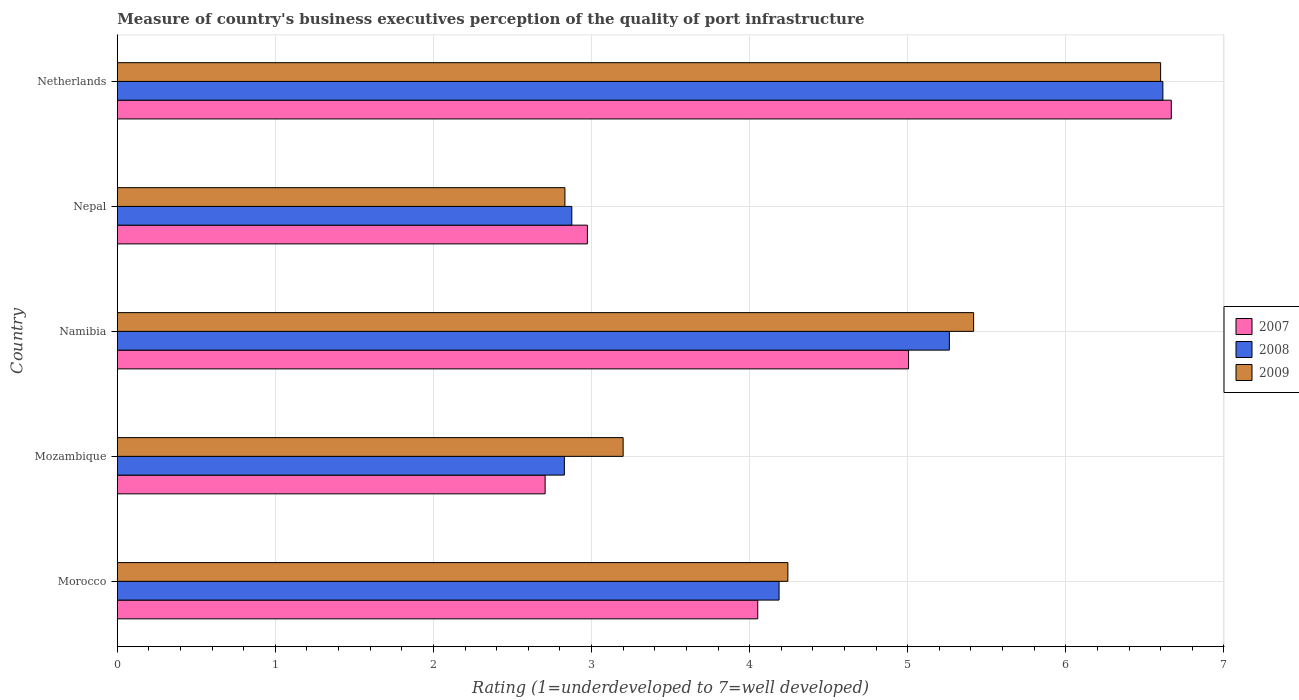How many groups of bars are there?
Ensure brevity in your answer.  5. Are the number of bars on each tick of the Y-axis equal?
Keep it short and to the point. Yes. How many bars are there on the 2nd tick from the bottom?
Offer a terse response. 3. What is the label of the 4th group of bars from the top?
Ensure brevity in your answer.  Mozambique. In how many cases, is the number of bars for a given country not equal to the number of legend labels?
Offer a terse response. 0. What is the ratings of the quality of port infrastructure in 2009 in Mozambique?
Provide a succinct answer. 3.2. Across all countries, what is the maximum ratings of the quality of port infrastructure in 2009?
Your answer should be very brief. 6.6. Across all countries, what is the minimum ratings of the quality of port infrastructure in 2007?
Your response must be concise. 2.71. In which country was the ratings of the quality of port infrastructure in 2007 minimum?
Provide a succinct answer. Mozambique. What is the total ratings of the quality of port infrastructure in 2007 in the graph?
Give a very brief answer. 21.4. What is the difference between the ratings of the quality of port infrastructure in 2009 in Nepal and that in Netherlands?
Make the answer very short. -3.77. What is the difference between the ratings of the quality of port infrastructure in 2008 in Namibia and the ratings of the quality of port infrastructure in 2009 in Mozambique?
Your answer should be very brief. 2.06. What is the average ratings of the quality of port infrastructure in 2008 per country?
Ensure brevity in your answer.  4.35. What is the difference between the ratings of the quality of port infrastructure in 2008 and ratings of the quality of port infrastructure in 2007 in Netherlands?
Give a very brief answer. -0.05. What is the ratio of the ratings of the quality of port infrastructure in 2009 in Mozambique to that in Namibia?
Provide a succinct answer. 0.59. Is the difference between the ratings of the quality of port infrastructure in 2008 in Morocco and Mozambique greater than the difference between the ratings of the quality of port infrastructure in 2007 in Morocco and Mozambique?
Keep it short and to the point. Yes. What is the difference between the highest and the second highest ratings of the quality of port infrastructure in 2007?
Offer a very short reply. 1.66. What is the difference between the highest and the lowest ratings of the quality of port infrastructure in 2008?
Make the answer very short. 3.79. What does the 1st bar from the top in Namibia represents?
Provide a succinct answer. 2009. What does the 2nd bar from the bottom in Netherlands represents?
Your response must be concise. 2008. Is it the case that in every country, the sum of the ratings of the quality of port infrastructure in 2009 and ratings of the quality of port infrastructure in 2008 is greater than the ratings of the quality of port infrastructure in 2007?
Keep it short and to the point. Yes. How many bars are there?
Offer a terse response. 15. Are all the bars in the graph horizontal?
Ensure brevity in your answer.  Yes. Are the values on the major ticks of X-axis written in scientific E-notation?
Offer a terse response. No. How are the legend labels stacked?
Your answer should be compact. Vertical. What is the title of the graph?
Your response must be concise. Measure of country's business executives perception of the quality of port infrastructure. Does "1992" appear as one of the legend labels in the graph?
Make the answer very short. No. What is the label or title of the X-axis?
Provide a short and direct response. Rating (1=underdeveloped to 7=well developed). What is the Rating (1=underdeveloped to 7=well developed) in 2007 in Morocco?
Your answer should be very brief. 4.05. What is the Rating (1=underdeveloped to 7=well developed) in 2008 in Morocco?
Provide a short and direct response. 4.19. What is the Rating (1=underdeveloped to 7=well developed) of 2009 in Morocco?
Offer a terse response. 4.24. What is the Rating (1=underdeveloped to 7=well developed) in 2007 in Mozambique?
Provide a succinct answer. 2.71. What is the Rating (1=underdeveloped to 7=well developed) of 2008 in Mozambique?
Offer a very short reply. 2.83. What is the Rating (1=underdeveloped to 7=well developed) of 2009 in Mozambique?
Give a very brief answer. 3.2. What is the Rating (1=underdeveloped to 7=well developed) of 2007 in Namibia?
Your answer should be very brief. 5.01. What is the Rating (1=underdeveloped to 7=well developed) in 2008 in Namibia?
Give a very brief answer. 5.26. What is the Rating (1=underdeveloped to 7=well developed) in 2009 in Namibia?
Offer a terse response. 5.42. What is the Rating (1=underdeveloped to 7=well developed) of 2007 in Nepal?
Give a very brief answer. 2.97. What is the Rating (1=underdeveloped to 7=well developed) in 2008 in Nepal?
Your answer should be compact. 2.88. What is the Rating (1=underdeveloped to 7=well developed) of 2009 in Nepal?
Your answer should be compact. 2.83. What is the Rating (1=underdeveloped to 7=well developed) of 2007 in Netherlands?
Offer a terse response. 6.67. What is the Rating (1=underdeveloped to 7=well developed) in 2008 in Netherlands?
Provide a succinct answer. 6.61. What is the Rating (1=underdeveloped to 7=well developed) of 2009 in Netherlands?
Your answer should be very brief. 6.6. Across all countries, what is the maximum Rating (1=underdeveloped to 7=well developed) in 2007?
Your answer should be very brief. 6.67. Across all countries, what is the maximum Rating (1=underdeveloped to 7=well developed) in 2008?
Your answer should be very brief. 6.61. Across all countries, what is the maximum Rating (1=underdeveloped to 7=well developed) of 2009?
Keep it short and to the point. 6.6. Across all countries, what is the minimum Rating (1=underdeveloped to 7=well developed) of 2007?
Your answer should be compact. 2.71. Across all countries, what is the minimum Rating (1=underdeveloped to 7=well developed) in 2008?
Ensure brevity in your answer.  2.83. Across all countries, what is the minimum Rating (1=underdeveloped to 7=well developed) of 2009?
Your answer should be compact. 2.83. What is the total Rating (1=underdeveloped to 7=well developed) of 2007 in the graph?
Provide a succinct answer. 21.4. What is the total Rating (1=underdeveloped to 7=well developed) in 2008 in the graph?
Your response must be concise. 21.77. What is the total Rating (1=underdeveloped to 7=well developed) in 2009 in the graph?
Give a very brief answer. 22.29. What is the difference between the Rating (1=underdeveloped to 7=well developed) in 2007 in Morocco and that in Mozambique?
Your answer should be very brief. 1.34. What is the difference between the Rating (1=underdeveloped to 7=well developed) of 2008 in Morocco and that in Mozambique?
Ensure brevity in your answer.  1.36. What is the difference between the Rating (1=underdeveloped to 7=well developed) in 2009 in Morocco and that in Mozambique?
Keep it short and to the point. 1.04. What is the difference between the Rating (1=underdeveloped to 7=well developed) of 2007 in Morocco and that in Namibia?
Your response must be concise. -0.95. What is the difference between the Rating (1=underdeveloped to 7=well developed) in 2008 in Morocco and that in Namibia?
Offer a very short reply. -1.08. What is the difference between the Rating (1=underdeveloped to 7=well developed) in 2009 in Morocco and that in Namibia?
Keep it short and to the point. -1.18. What is the difference between the Rating (1=underdeveloped to 7=well developed) of 2007 in Morocco and that in Nepal?
Provide a short and direct response. 1.08. What is the difference between the Rating (1=underdeveloped to 7=well developed) of 2008 in Morocco and that in Nepal?
Ensure brevity in your answer.  1.31. What is the difference between the Rating (1=underdeveloped to 7=well developed) of 2009 in Morocco and that in Nepal?
Provide a succinct answer. 1.41. What is the difference between the Rating (1=underdeveloped to 7=well developed) of 2007 in Morocco and that in Netherlands?
Keep it short and to the point. -2.62. What is the difference between the Rating (1=underdeveloped to 7=well developed) in 2008 in Morocco and that in Netherlands?
Your answer should be compact. -2.43. What is the difference between the Rating (1=underdeveloped to 7=well developed) of 2009 in Morocco and that in Netherlands?
Ensure brevity in your answer.  -2.36. What is the difference between the Rating (1=underdeveloped to 7=well developed) of 2007 in Mozambique and that in Namibia?
Your response must be concise. -2.3. What is the difference between the Rating (1=underdeveloped to 7=well developed) in 2008 in Mozambique and that in Namibia?
Give a very brief answer. -2.44. What is the difference between the Rating (1=underdeveloped to 7=well developed) of 2009 in Mozambique and that in Namibia?
Your response must be concise. -2.22. What is the difference between the Rating (1=underdeveloped to 7=well developed) in 2007 in Mozambique and that in Nepal?
Ensure brevity in your answer.  -0.27. What is the difference between the Rating (1=underdeveloped to 7=well developed) of 2008 in Mozambique and that in Nepal?
Your response must be concise. -0.05. What is the difference between the Rating (1=underdeveloped to 7=well developed) of 2009 in Mozambique and that in Nepal?
Provide a succinct answer. 0.37. What is the difference between the Rating (1=underdeveloped to 7=well developed) in 2007 in Mozambique and that in Netherlands?
Provide a succinct answer. -3.96. What is the difference between the Rating (1=underdeveloped to 7=well developed) in 2008 in Mozambique and that in Netherlands?
Your answer should be very brief. -3.79. What is the difference between the Rating (1=underdeveloped to 7=well developed) of 2009 in Mozambique and that in Netherlands?
Ensure brevity in your answer.  -3.4. What is the difference between the Rating (1=underdeveloped to 7=well developed) of 2007 in Namibia and that in Nepal?
Provide a short and direct response. 2.03. What is the difference between the Rating (1=underdeveloped to 7=well developed) of 2008 in Namibia and that in Nepal?
Make the answer very short. 2.39. What is the difference between the Rating (1=underdeveloped to 7=well developed) in 2009 in Namibia and that in Nepal?
Keep it short and to the point. 2.59. What is the difference between the Rating (1=underdeveloped to 7=well developed) in 2007 in Namibia and that in Netherlands?
Provide a succinct answer. -1.66. What is the difference between the Rating (1=underdeveloped to 7=well developed) of 2008 in Namibia and that in Netherlands?
Give a very brief answer. -1.35. What is the difference between the Rating (1=underdeveloped to 7=well developed) of 2009 in Namibia and that in Netherlands?
Keep it short and to the point. -1.18. What is the difference between the Rating (1=underdeveloped to 7=well developed) in 2007 in Nepal and that in Netherlands?
Keep it short and to the point. -3.69. What is the difference between the Rating (1=underdeveloped to 7=well developed) of 2008 in Nepal and that in Netherlands?
Give a very brief answer. -3.74. What is the difference between the Rating (1=underdeveloped to 7=well developed) of 2009 in Nepal and that in Netherlands?
Offer a very short reply. -3.77. What is the difference between the Rating (1=underdeveloped to 7=well developed) in 2007 in Morocco and the Rating (1=underdeveloped to 7=well developed) in 2008 in Mozambique?
Your answer should be compact. 1.22. What is the difference between the Rating (1=underdeveloped to 7=well developed) in 2007 in Morocco and the Rating (1=underdeveloped to 7=well developed) in 2009 in Mozambique?
Ensure brevity in your answer.  0.85. What is the difference between the Rating (1=underdeveloped to 7=well developed) in 2008 in Morocco and the Rating (1=underdeveloped to 7=well developed) in 2009 in Mozambique?
Make the answer very short. 0.99. What is the difference between the Rating (1=underdeveloped to 7=well developed) of 2007 in Morocco and the Rating (1=underdeveloped to 7=well developed) of 2008 in Namibia?
Make the answer very short. -1.21. What is the difference between the Rating (1=underdeveloped to 7=well developed) of 2007 in Morocco and the Rating (1=underdeveloped to 7=well developed) of 2009 in Namibia?
Keep it short and to the point. -1.37. What is the difference between the Rating (1=underdeveloped to 7=well developed) in 2008 in Morocco and the Rating (1=underdeveloped to 7=well developed) in 2009 in Namibia?
Your answer should be very brief. -1.23. What is the difference between the Rating (1=underdeveloped to 7=well developed) in 2007 in Morocco and the Rating (1=underdeveloped to 7=well developed) in 2008 in Nepal?
Provide a short and direct response. 1.18. What is the difference between the Rating (1=underdeveloped to 7=well developed) in 2007 in Morocco and the Rating (1=underdeveloped to 7=well developed) in 2009 in Nepal?
Your response must be concise. 1.22. What is the difference between the Rating (1=underdeveloped to 7=well developed) in 2008 in Morocco and the Rating (1=underdeveloped to 7=well developed) in 2009 in Nepal?
Give a very brief answer. 1.35. What is the difference between the Rating (1=underdeveloped to 7=well developed) in 2007 in Morocco and the Rating (1=underdeveloped to 7=well developed) in 2008 in Netherlands?
Offer a terse response. -2.56. What is the difference between the Rating (1=underdeveloped to 7=well developed) of 2007 in Morocco and the Rating (1=underdeveloped to 7=well developed) of 2009 in Netherlands?
Provide a succinct answer. -2.55. What is the difference between the Rating (1=underdeveloped to 7=well developed) of 2008 in Morocco and the Rating (1=underdeveloped to 7=well developed) of 2009 in Netherlands?
Offer a terse response. -2.41. What is the difference between the Rating (1=underdeveloped to 7=well developed) in 2007 in Mozambique and the Rating (1=underdeveloped to 7=well developed) in 2008 in Namibia?
Your answer should be compact. -2.56. What is the difference between the Rating (1=underdeveloped to 7=well developed) in 2007 in Mozambique and the Rating (1=underdeveloped to 7=well developed) in 2009 in Namibia?
Ensure brevity in your answer.  -2.71. What is the difference between the Rating (1=underdeveloped to 7=well developed) in 2008 in Mozambique and the Rating (1=underdeveloped to 7=well developed) in 2009 in Namibia?
Your answer should be very brief. -2.59. What is the difference between the Rating (1=underdeveloped to 7=well developed) of 2007 in Mozambique and the Rating (1=underdeveloped to 7=well developed) of 2008 in Nepal?
Offer a terse response. -0.17. What is the difference between the Rating (1=underdeveloped to 7=well developed) of 2007 in Mozambique and the Rating (1=underdeveloped to 7=well developed) of 2009 in Nepal?
Keep it short and to the point. -0.13. What is the difference between the Rating (1=underdeveloped to 7=well developed) of 2008 in Mozambique and the Rating (1=underdeveloped to 7=well developed) of 2009 in Nepal?
Your response must be concise. -0. What is the difference between the Rating (1=underdeveloped to 7=well developed) in 2007 in Mozambique and the Rating (1=underdeveloped to 7=well developed) in 2008 in Netherlands?
Your answer should be compact. -3.91. What is the difference between the Rating (1=underdeveloped to 7=well developed) of 2007 in Mozambique and the Rating (1=underdeveloped to 7=well developed) of 2009 in Netherlands?
Make the answer very short. -3.89. What is the difference between the Rating (1=underdeveloped to 7=well developed) of 2008 in Mozambique and the Rating (1=underdeveloped to 7=well developed) of 2009 in Netherlands?
Provide a short and direct response. -3.77. What is the difference between the Rating (1=underdeveloped to 7=well developed) in 2007 in Namibia and the Rating (1=underdeveloped to 7=well developed) in 2008 in Nepal?
Provide a short and direct response. 2.13. What is the difference between the Rating (1=underdeveloped to 7=well developed) in 2007 in Namibia and the Rating (1=underdeveloped to 7=well developed) in 2009 in Nepal?
Keep it short and to the point. 2.17. What is the difference between the Rating (1=underdeveloped to 7=well developed) in 2008 in Namibia and the Rating (1=underdeveloped to 7=well developed) in 2009 in Nepal?
Your response must be concise. 2.43. What is the difference between the Rating (1=underdeveloped to 7=well developed) in 2007 in Namibia and the Rating (1=underdeveloped to 7=well developed) in 2008 in Netherlands?
Give a very brief answer. -1.61. What is the difference between the Rating (1=underdeveloped to 7=well developed) of 2007 in Namibia and the Rating (1=underdeveloped to 7=well developed) of 2009 in Netherlands?
Provide a succinct answer. -1.59. What is the difference between the Rating (1=underdeveloped to 7=well developed) in 2008 in Namibia and the Rating (1=underdeveloped to 7=well developed) in 2009 in Netherlands?
Keep it short and to the point. -1.34. What is the difference between the Rating (1=underdeveloped to 7=well developed) in 2007 in Nepal and the Rating (1=underdeveloped to 7=well developed) in 2008 in Netherlands?
Provide a succinct answer. -3.64. What is the difference between the Rating (1=underdeveloped to 7=well developed) in 2007 in Nepal and the Rating (1=underdeveloped to 7=well developed) in 2009 in Netherlands?
Provide a succinct answer. -3.63. What is the difference between the Rating (1=underdeveloped to 7=well developed) in 2008 in Nepal and the Rating (1=underdeveloped to 7=well developed) in 2009 in Netherlands?
Your answer should be very brief. -3.72. What is the average Rating (1=underdeveloped to 7=well developed) of 2007 per country?
Offer a terse response. 4.28. What is the average Rating (1=underdeveloped to 7=well developed) in 2008 per country?
Provide a succinct answer. 4.35. What is the average Rating (1=underdeveloped to 7=well developed) of 2009 per country?
Offer a terse response. 4.46. What is the difference between the Rating (1=underdeveloped to 7=well developed) in 2007 and Rating (1=underdeveloped to 7=well developed) in 2008 in Morocco?
Ensure brevity in your answer.  -0.13. What is the difference between the Rating (1=underdeveloped to 7=well developed) of 2007 and Rating (1=underdeveloped to 7=well developed) of 2009 in Morocco?
Ensure brevity in your answer.  -0.19. What is the difference between the Rating (1=underdeveloped to 7=well developed) in 2008 and Rating (1=underdeveloped to 7=well developed) in 2009 in Morocco?
Keep it short and to the point. -0.06. What is the difference between the Rating (1=underdeveloped to 7=well developed) in 2007 and Rating (1=underdeveloped to 7=well developed) in 2008 in Mozambique?
Offer a terse response. -0.12. What is the difference between the Rating (1=underdeveloped to 7=well developed) in 2007 and Rating (1=underdeveloped to 7=well developed) in 2009 in Mozambique?
Offer a very short reply. -0.49. What is the difference between the Rating (1=underdeveloped to 7=well developed) of 2008 and Rating (1=underdeveloped to 7=well developed) of 2009 in Mozambique?
Your answer should be compact. -0.37. What is the difference between the Rating (1=underdeveloped to 7=well developed) of 2007 and Rating (1=underdeveloped to 7=well developed) of 2008 in Namibia?
Offer a terse response. -0.26. What is the difference between the Rating (1=underdeveloped to 7=well developed) of 2007 and Rating (1=underdeveloped to 7=well developed) of 2009 in Namibia?
Offer a very short reply. -0.41. What is the difference between the Rating (1=underdeveloped to 7=well developed) in 2008 and Rating (1=underdeveloped to 7=well developed) in 2009 in Namibia?
Your answer should be compact. -0.15. What is the difference between the Rating (1=underdeveloped to 7=well developed) in 2007 and Rating (1=underdeveloped to 7=well developed) in 2008 in Nepal?
Give a very brief answer. 0.1. What is the difference between the Rating (1=underdeveloped to 7=well developed) of 2007 and Rating (1=underdeveloped to 7=well developed) of 2009 in Nepal?
Ensure brevity in your answer.  0.14. What is the difference between the Rating (1=underdeveloped to 7=well developed) of 2008 and Rating (1=underdeveloped to 7=well developed) of 2009 in Nepal?
Provide a short and direct response. 0.04. What is the difference between the Rating (1=underdeveloped to 7=well developed) in 2007 and Rating (1=underdeveloped to 7=well developed) in 2008 in Netherlands?
Offer a terse response. 0.05. What is the difference between the Rating (1=underdeveloped to 7=well developed) of 2007 and Rating (1=underdeveloped to 7=well developed) of 2009 in Netherlands?
Your response must be concise. 0.07. What is the difference between the Rating (1=underdeveloped to 7=well developed) of 2008 and Rating (1=underdeveloped to 7=well developed) of 2009 in Netherlands?
Offer a terse response. 0.01. What is the ratio of the Rating (1=underdeveloped to 7=well developed) in 2007 in Morocco to that in Mozambique?
Offer a terse response. 1.5. What is the ratio of the Rating (1=underdeveloped to 7=well developed) of 2008 in Morocco to that in Mozambique?
Your answer should be compact. 1.48. What is the ratio of the Rating (1=underdeveloped to 7=well developed) of 2009 in Morocco to that in Mozambique?
Your answer should be compact. 1.33. What is the ratio of the Rating (1=underdeveloped to 7=well developed) of 2007 in Morocco to that in Namibia?
Give a very brief answer. 0.81. What is the ratio of the Rating (1=underdeveloped to 7=well developed) in 2008 in Morocco to that in Namibia?
Make the answer very short. 0.8. What is the ratio of the Rating (1=underdeveloped to 7=well developed) in 2009 in Morocco to that in Namibia?
Ensure brevity in your answer.  0.78. What is the ratio of the Rating (1=underdeveloped to 7=well developed) in 2007 in Morocco to that in Nepal?
Your answer should be very brief. 1.36. What is the ratio of the Rating (1=underdeveloped to 7=well developed) in 2008 in Morocco to that in Nepal?
Your response must be concise. 1.46. What is the ratio of the Rating (1=underdeveloped to 7=well developed) of 2009 in Morocco to that in Nepal?
Offer a terse response. 1.5. What is the ratio of the Rating (1=underdeveloped to 7=well developed) of 2007 in Morocco to that in Netherlands?
Provide a succinct answer. 0.61. What is the ratio of the Rating (1=underdeveloped to 7=well developed) in 2008 in Morocco to that in Netherlands?
Provide a succinct answer. 0.63. What is the ratio of the Rating (1=underdeveloped to 7=well developed) in 2009 in Morocco to that in Netherlands?
Make the answer very short. 0.64. What is the ratio of the Rating (1=underdeveloped to 7=well developed) of 2007 in Mozambique to that in Namibia?
Your answer should be very brief. 0.54. What is the ratio of the Rating (1=underdeveloped to 7=well developed) of 2008 in Mozambique to that in Namibia?
Provide a succinct answer. 0.54. What is the ratio of the Rating (1=underdeveloped to 7=well developed) of 2009 in Mozambique to that in Namibia?
Offer a very short reply. 0.59. What is the ratio of the Rating (1=underdeveloped to 7=well developed) in 2007 in Mozambique to that in Nepal?
Provide a succinct answer. 0.91. What is the ratio of the Rating (1=underdeveloped to 7=well developed) in 2008 in Mozambique to that in Nepal?
Provide a succinct answer. 0.98. What is the ratio of the Rating (1=underdeveloped to 7=well developed) of 2009 in Mozambique to that in Nepal?
Ensure brevity in your answer.  1.13. What is the ratio of the Rating (1=underdeveloped to 7=well developed) in 2007 in Mozambique to that in Netherlands?
Provide a succinct answer. 0.41. What is the ratio of the Rating (1=underdeveloped to 7=well developed) in 2008 in Mozambique to that in Netherlands?
Keep it short and to the point. 0.43. What is the ratio of the Rating (1=underdeveloped to 7=well developed) of 2009 in Mozambique to that in Netherlands?
Provide a short and direct response. 0.48. What is the ratio of the Rating (1=underdeveloped to 7=well developed) of 2007 in Namibia to that in Nepal?
Give a very brief answer. 1.68. What is the ratio of the Rating (1=underdeveloped to 7=well developed) in 2008 in Namibia to that in Nepal?
Make the answer very short. 1.83. What is the ratio of the Rating (1=underdeveloped to 7=well developed) of 2009 in Namibia to that in Nepal?
Provide a succinct answer. 1.91. What is the ratio of the Rating (1=underdeveloped to 7=well developed) of 2007 in Namibia to that in Netherlands?
Make the answer very short. 0.75. What is the ratio of the Rating (1=underdeveloped to 7=well developed) in 2008 in Namibia to that in Netherlands?
Your answer should be compact. 0.8. What is the ratio of the Rating (1=underdeveloped to 7=well developed) in 2009 in Namibia to that in Netherlands?
Your answer should be compact. 0.82. What is the ratio of the Rating (1=underdeveloped to 7=well developed) of 2007 in Nepal to that in Netherlands?
Offer a terse response. 0.45. What is the ratio of the Rating (1=underdeveloped to 7=well developed) of 2008 in Nepal to that in Netherlands?
Provide a short and direct response. 0.43. What is the ratio of the Rating (1=underdeveloped to 7=well developed) in 2009 in Nepal to that in Netherlands?
Keep it short and to the point. 0.43. What is the difference between the highest and the second highest Rating (1=underdeveloped to 7=well developed) in 2007?
Your response must be concise. 1.66. What is the difference between the highest and the second highest Rating (1=underdeveloped to 7=well developed) in 2008?
Keep it short and to the point. 1.35. What is the difference between the highest and the second highest Rating (1=underdeveloped to 7=well developed) in 2009?
Your answer should be very brief. 1.18. What is the difference between the highest and the lowest Rating (1=underdeveloped to 7=well developed) of 2007?
Your answer should be very brief. 3.96. What is the difference between the highest and the lowest Rating (1=underdeveloped to 7=well developed) in 2008?
Offer a terse response. 3.79. What is the difference between the highest and the lowest Rating (1=underdeveloped to 7=well developed) in 2009?
Your answer should be very brief. 3.77. 